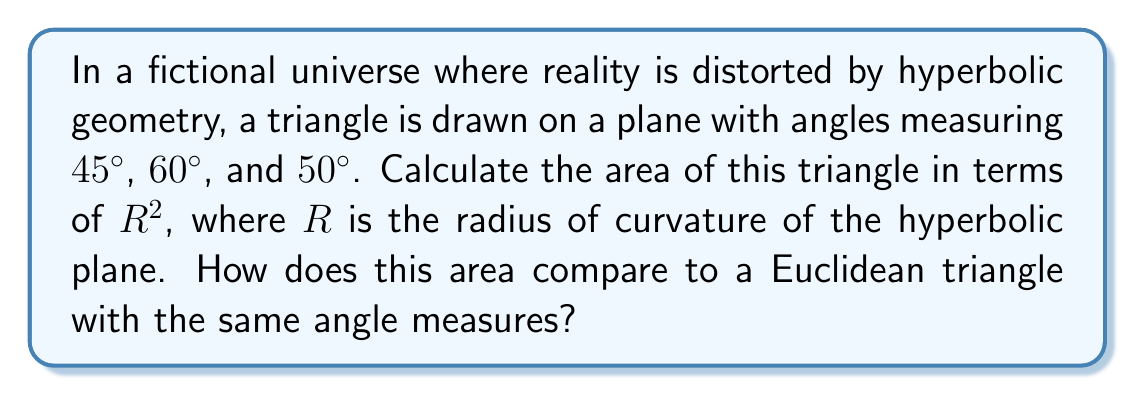What is the answer to this math problem? 1) In hyperbolic geometry, the sum of angles in a triangle is less than 180°. Let's calculate the angle defect:

   Angle sum = $45° + 60° + 50° = 155°$
   Angle defect = $180° - 155° = 25° = \frac{25\pi}{180}$ radians

2) The area of a triangle in hyperbolic geometry is given by the formula:

   $A = (\pi - (\alpha + \beta + \gamma))R^2$

   Where $\alpha$, $\beta$, and $\gamma$ are the angles in radians, and $R$ is the radius of curvature.

3) Substituting our angle defect:

   $A = \frac{25\pi}{180}R^2$

4) Simplifying:

   $A = \frac{5\pi}{36}R^2$

5) In Euclidean geometry, the area of a triangle with these angles would be zero, as the angle sum (155°) is less than 180°, making such a triangle impossible.

6) The comparison shows that in this distorted reality, triangles with angle sums less than 180° not only exist but have positive areas, unlike in Euclidean space.
Answer: $\frac{5\pi}{36}R^2$ 